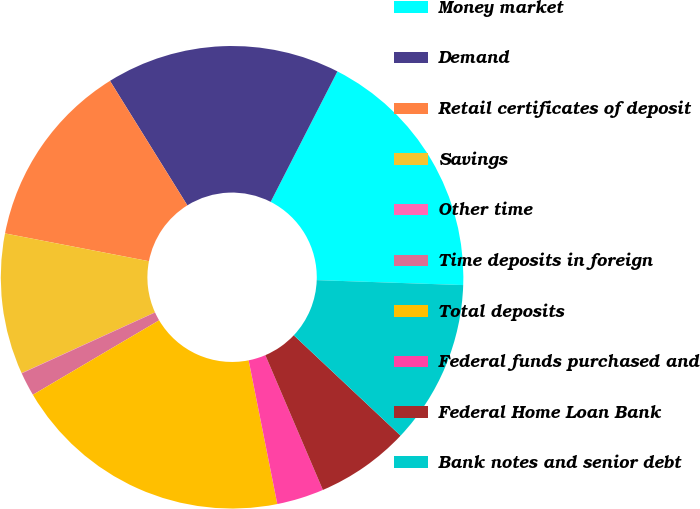Convert chart. <chart><loc_0><loc_0><loc_500><loc_500><pie_chart><fcel>Money market<fcel>Demand<fcel>Retail certificates of deposit<fcel>Savings<fcel>Other time<fcel>Time deposits in foreign<fcel>Total deposits<fcel>Federal funds purchased and<fcel>Federal Home Loan Bank<fcel>Bank notes and senior debt<nl><fcel>18.01%<fcel>16.38%<fcel>13.11%<fcel>9.84%<fcel>0.02%<fcel>1.66%<fcel>19.65%<fcel>3.29%<fcel>6.57%<fcel>11.47%<nl></chart> 